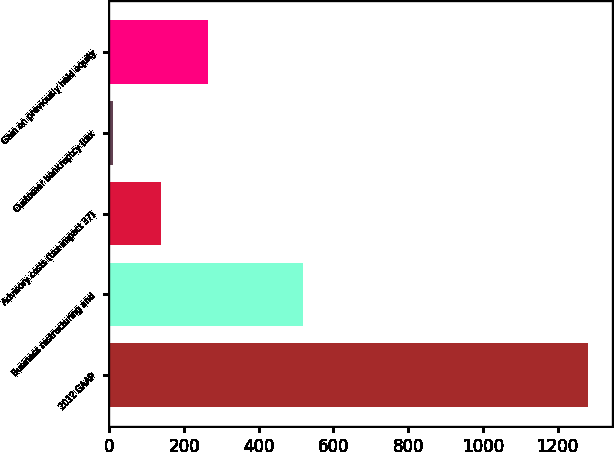Convert chart to OTSL. <chart><loc_0><loc_0><loc_500><loc_500><bar_chart><fcel>2012 GAAP<fcel>Business restructuring and<fcel>Advisory costs (tax impact 37)<fcel>Customer bankruptcy (tax<fcel>Gain on previously held equity<nl><fcel>1282.4<fcel>518.84<fcel>137.06<fcel>9.8<fcel>264.32<nl></chart> 